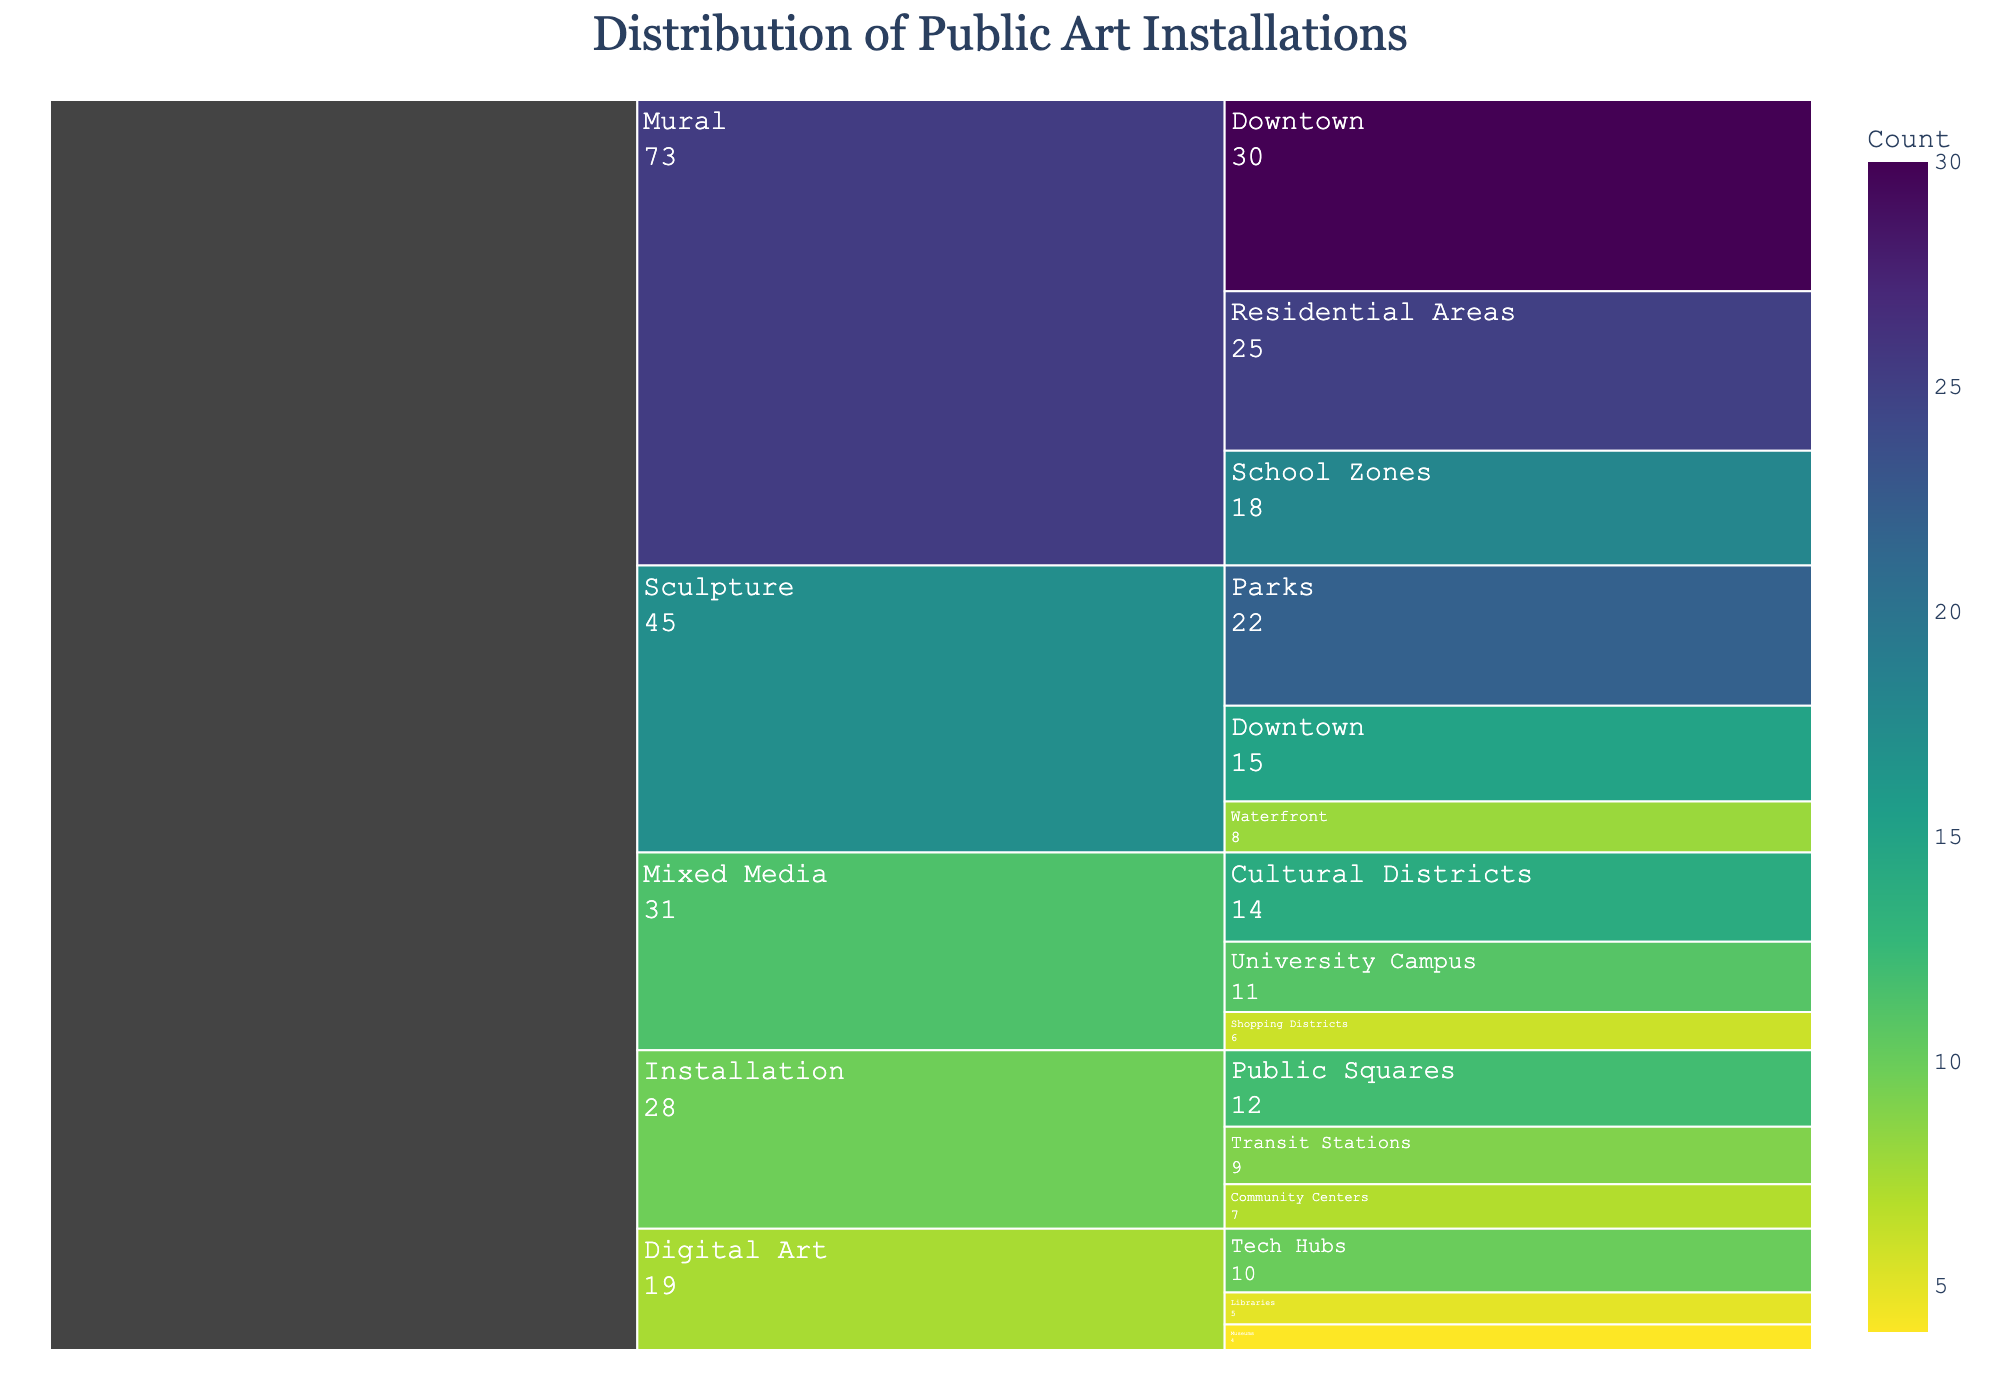Which location has the highest count of Murals? Look at the Murals section and identify the highest count. The possible locations are Downtown, Residential Areas, and School Zones. The highest count is 30 in Downtown.
Answer: Downtown What is the total count of public art installations in Park locations? Focus on the count of installations under the Parks location in the Sculpture medium. The count is 22.
Answer: 22 Are there more Sculptures or Murals in the city? Compare the total counts for Sculptures (15 + 22 + 8 = 45) and Murals (30 + 25 + 18 = 73). Murals have a higher total.
Answer: Murals What is the count difference between Sculptures and Installations in the city? First, sum the counts for Sculptures (45) and Installations (12 + 9 + 7 = 28). Then, compute the difference (45 - 28 = 17).
Answer: 17 Which public art medium has the least installations in Waterfront locations? Look at all the locations and identify Waterfront under Sculpture with a count of 8. Other mediums don't have this location.
Answer: Sculpture What's the most common medium for public art installations in Downtown locations? Compare the counts of Sculptures (15), Murals (30) in Downtown. Murals have the highest count.
Answer: Murals What is the average count of Mixed Media installations across all locations? Compute the total count for Mixed Media (14 + 11 + 6 = 31) and divide by the number of locations (3). The average is 31/3 = 10.33.
Answer: 10.33 Which medium has the fewest installations at public squares? The only medium listed at public squares is Installations with a count of 12.
Answer: Installations How many more Murals are there compared to Digital Art installations? Sum the counts for Murals (73) and Digital Art (10 + 5 + 4 = 19). Then, find the difference (73 - 19 = 54).
Answer: 54 What is the total number of art installations in residential areas, including Murals and Installations? Sum the counts of Murals in Residential Areas (25) and Installations in Community Centers (7). Total = 25 + 7 = 32.
Answer: 32 